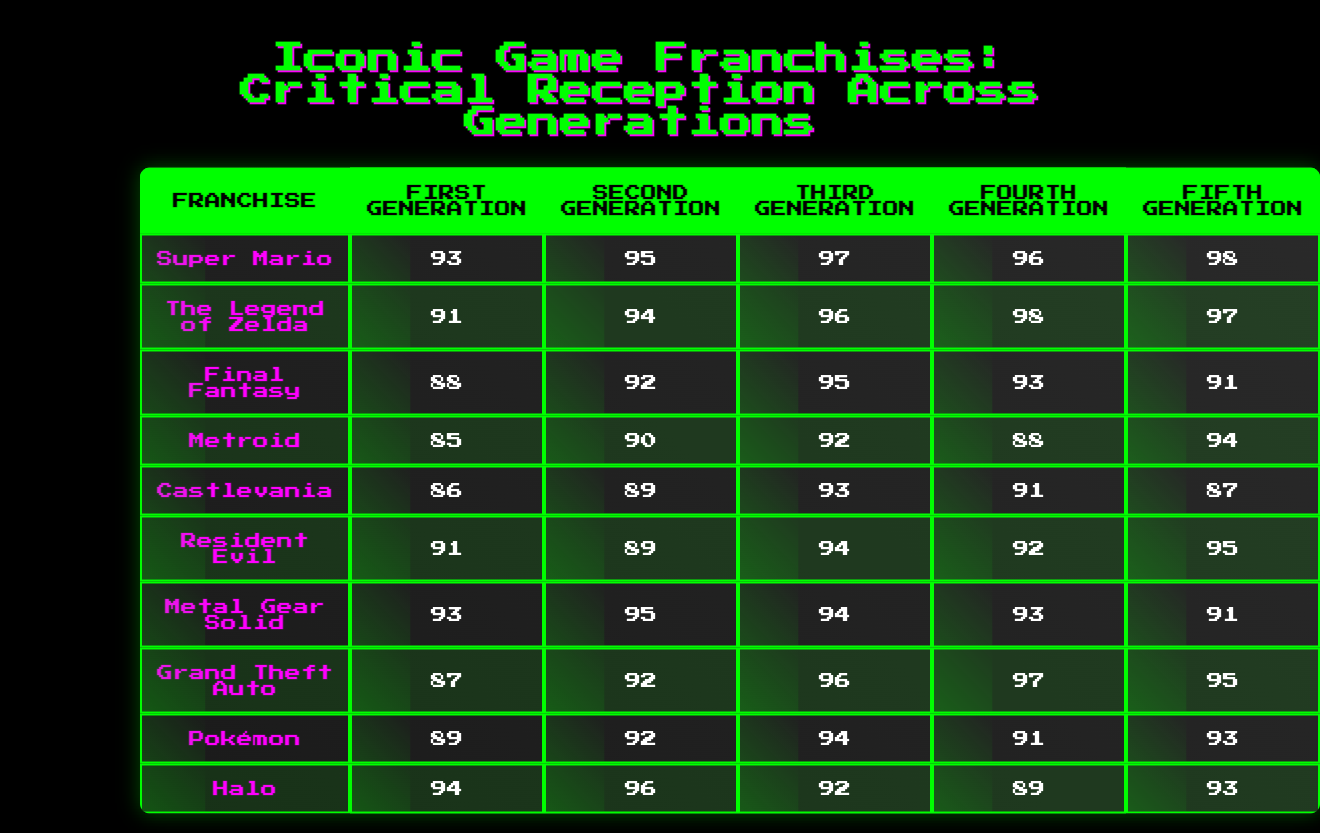What is the highest critical reception score for the Super Mario franchise? The Super Mario franchise has critical scores across generations of 93, 95, 97, 96, and 98. The highest score is 98 from the fifth generation.
Answer: 98 Which franchise received a lower score in the fourth generation than in the third generation? By comparing the scores, Resident Evil has a score of 92 in the fourth generation, which is lower than its third generation score of 94.
Answer: True What is the average score for the Final Fantasy franchise across all generations? The scores for Final Fantasy are 88, 92, 95, 93, and 91. The average is calculated by summing these scores (88 + 92 + 95 + 93 + 91 = 459) and dividing by the number of generations (459 / 5 = 91.8). Therefore, the average is approximately 92 when rounded.
Answer: 92 In which generation did the Legend of Zelda franchise achieve its highest score? The scores for The Legend of Zelda are 91, 94, 96, 98, and 97 across the generations. The highest score of 98 occurs in the fourth generation.
Answer: Fourth Generation Which franchise had its lowest score recorded in the first generation? Looking at the first generation scores: Super Mario (93), The Legend of Zelda (91), Final Fantasy (88), Metroid (85), Castlevania (86), Resident Evil (91), Metal Gear Solid (93), Grand Theft Auto (87), Pokémon (89), and Halo (94). The lowest score in the first generation is 85 from Metroid.
Answer: Metroid How many franchises have a score of 95 or higher in the fifth generation? In the fifth generation, the scores are: Super Mario (98), The Legend of Zelda (97), Final Fantasy (91), Metroid (94), Castlevania (87), Resident Evil (95), Metal Gear Solid (91), Grand Theft Auto (95), Pokémon (93), and Halo (93). Franchises with scores of 95 or higher in this generation are Super Mario, The Legend of Zelda, Resident Evil, and Grand Theft Auto, totaling 4 franchises.
Answer: 4 Which franchise has the most consistent scores (least variation) across all generations? To determine the consistency, we check the variation in scores: The Legend of Zelda has scores of 91, 94, 96, 98, 97 with a range of 7. Super Mario has scores of 93, 95, 97, 96, 98 with a range of 5. Thus, since Super Mario has the least variation among its scores, it is the most consistent.
Answer: Super Mario What is the sum of the scores for the Halo franchise across all generations? The scores for Halo across the generations are 94, 96, 92, 89, and 93. The sum is calculated as follows: 94 + 96 + 92 + 89 + 93 = 464.
Answer: 464 Name the franchises that scored 91 in at least one generation and indicate which generation it was. The franchises with a score of 91 are Resident Evil (second and fourth generations), Final Fantasy (first generation), and Grand Theft Auto (first and fifth generations).
Answer: Resident Evil (2nd, 4th), Final Fantasy (1st), Grand Theft Auto (1st, 5th) 